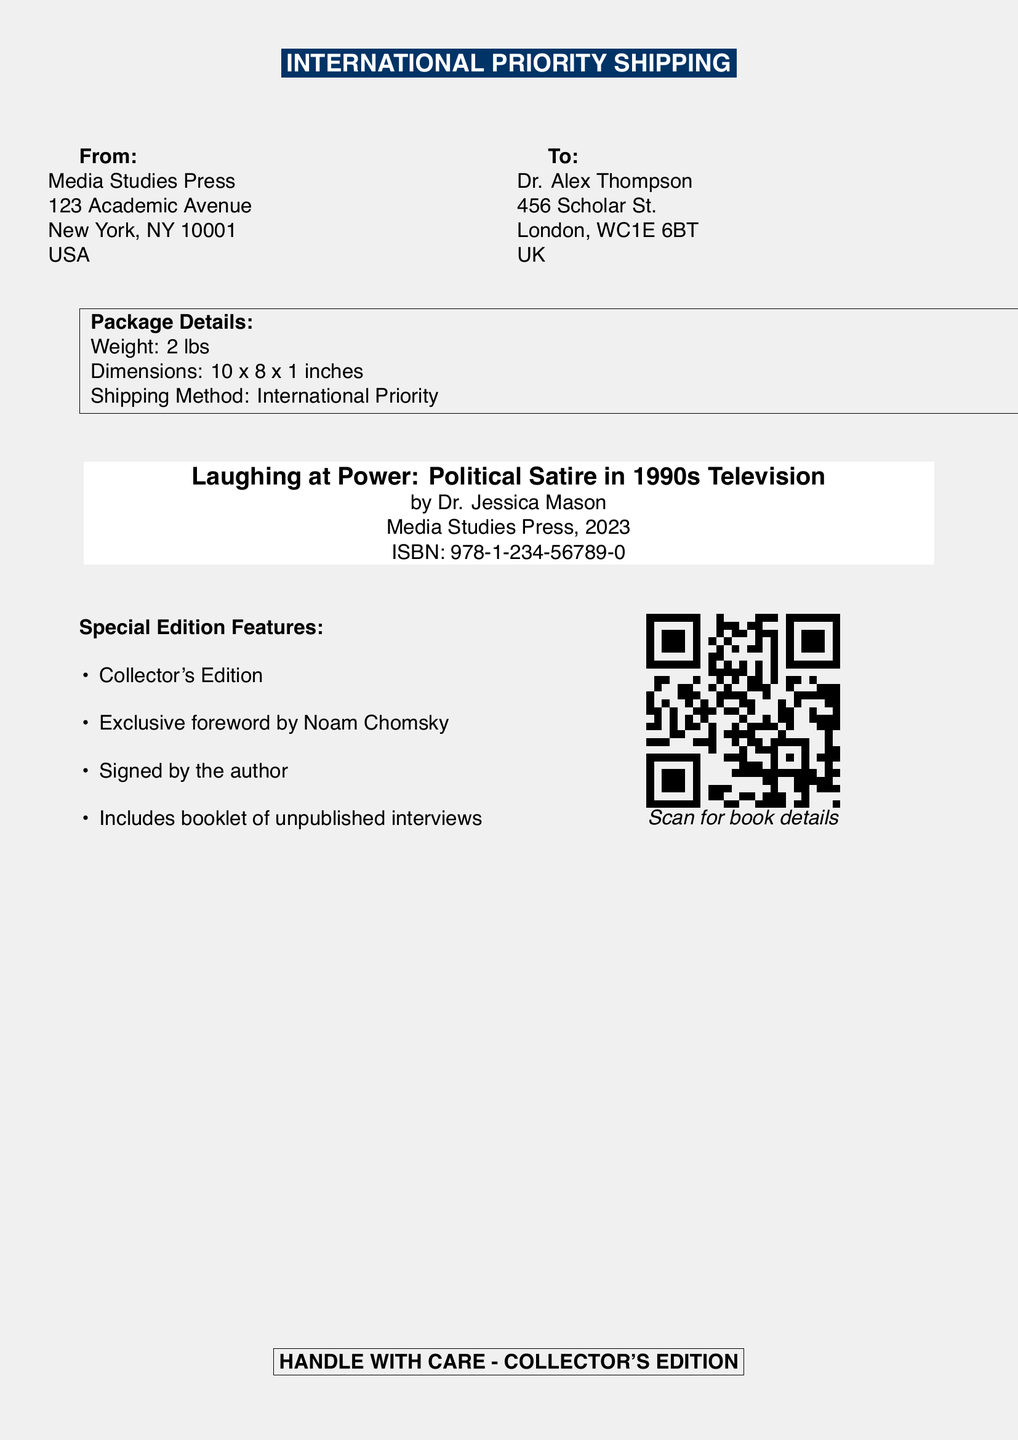What is the title of the book? The title of the book is stated prominently in the document.
Answer: Laughing at Power: Political Satire in 1990s Television Who is the author of the book? The document explicitly mentions the author's name under the title.
Answer: Dr. Jessica Mason What is the ISBN of the book? The ISBN is provided in the document for identification purposes.
Answer: 978-1-234-56789-0 What is the shipping method used? The shipping method is clearly labeled in the header of the document.
Answer: International Priority What features come with the special edition? The document lists specific features included with the special edition of the book.
Answer: Collector's Edition How much does the package weigh? The weight of the package is stated in the package details section.
Answer: 2 lbs What should be done with the package? The document includes a note on handling the package, indicating care should be taken.
Answer: HANDLE WITH CARE - COLLECTOR'S EDITION Who is the exclusive foreword written by? The special edition mentions a notable figure contributing to it.
Answer: Noam Chomsky What are the package dimensions? The dimensions are part of the package details provided in the document.
Answer: 10 x 8 x 1 inches 